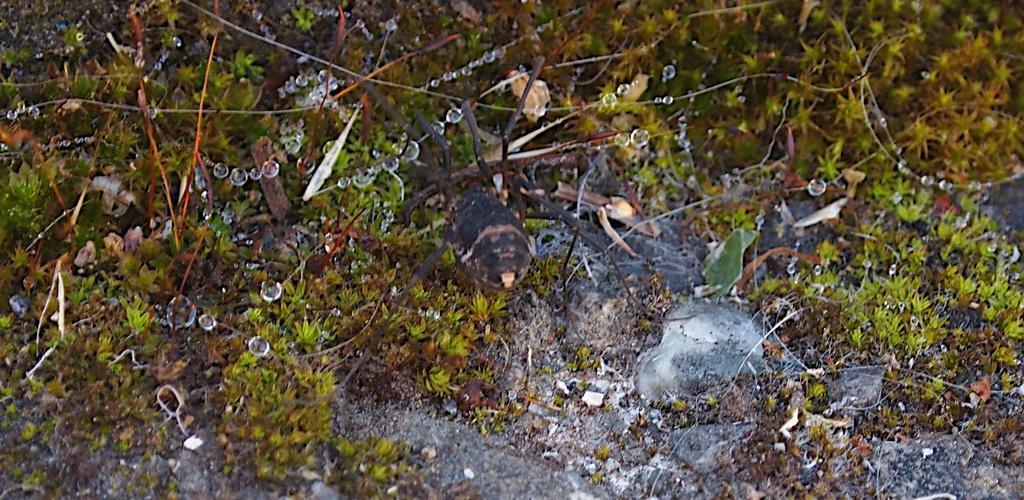How would you summarize this image in a sentence or two? This picture shows plants and we see few water droplets. 